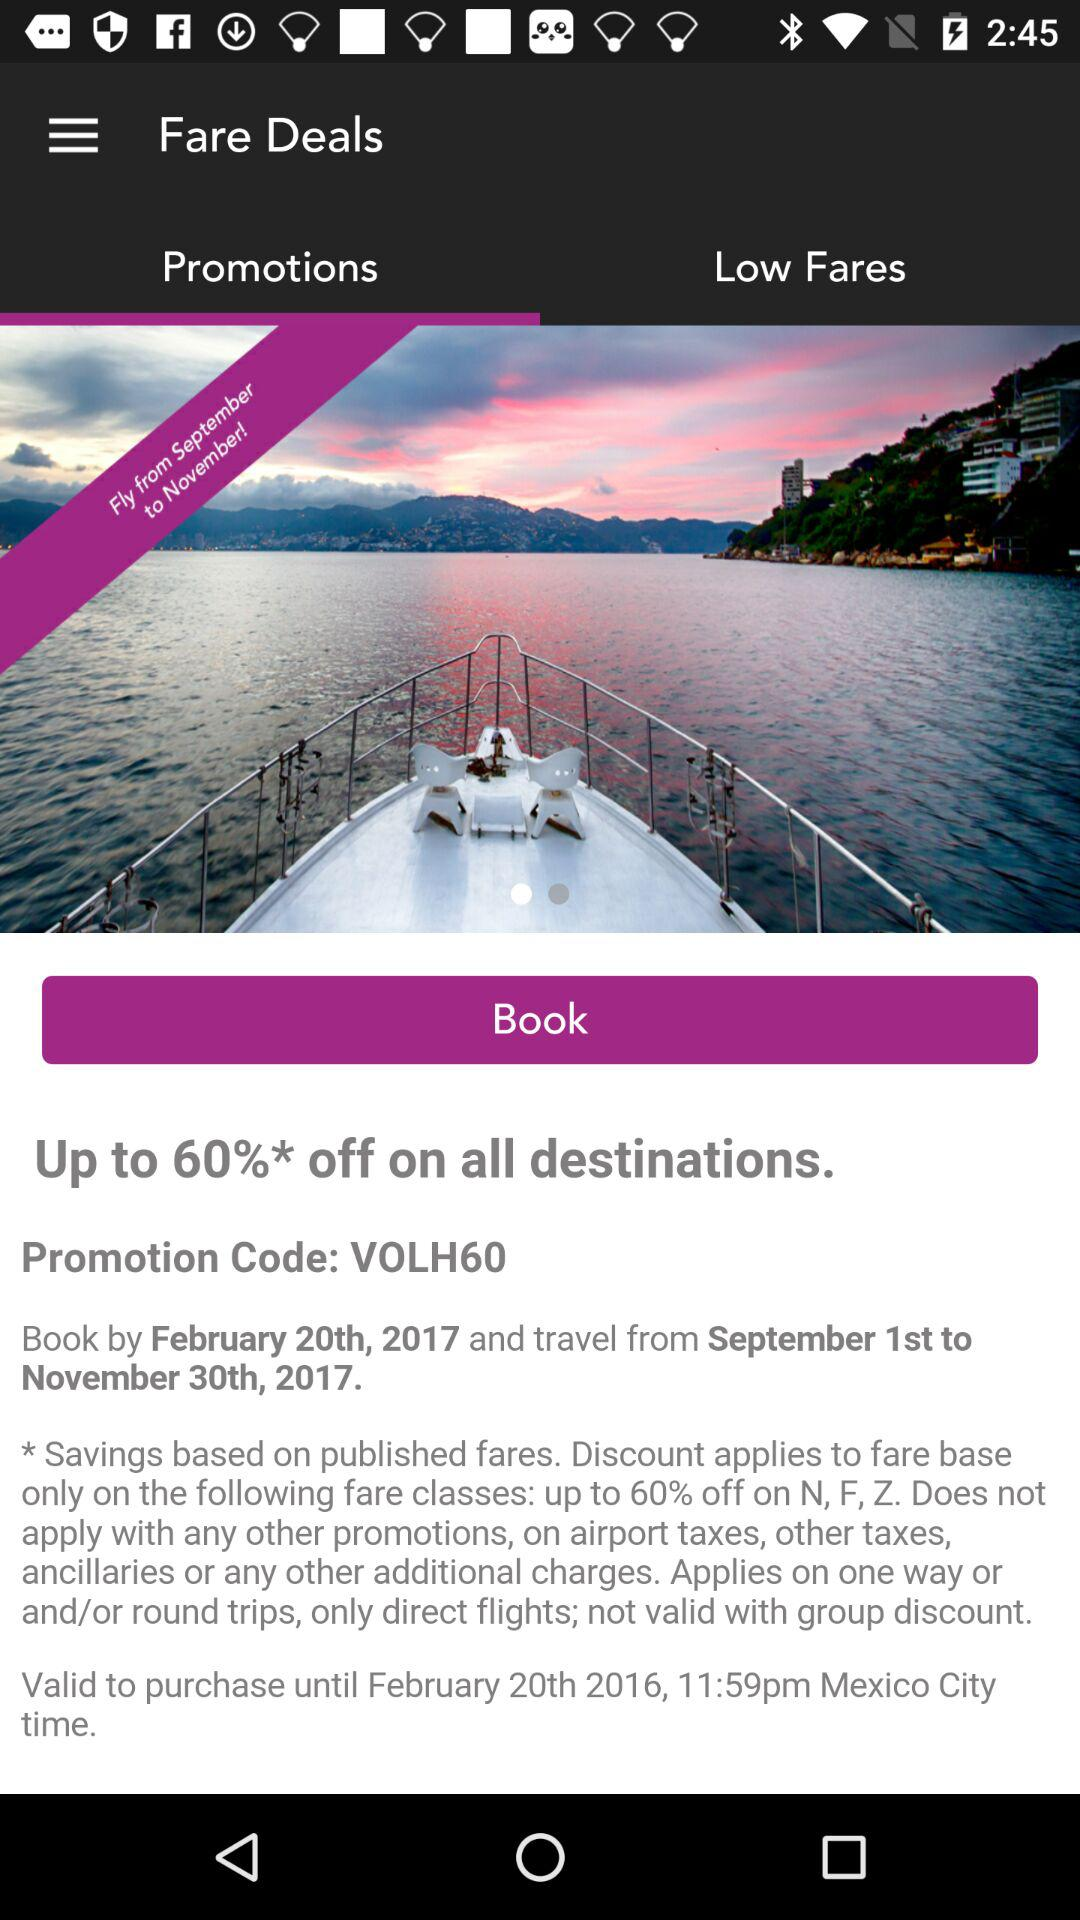Which month's range can we fly from? You can fly from September 1st, 2017 to November 30th, 2017. 